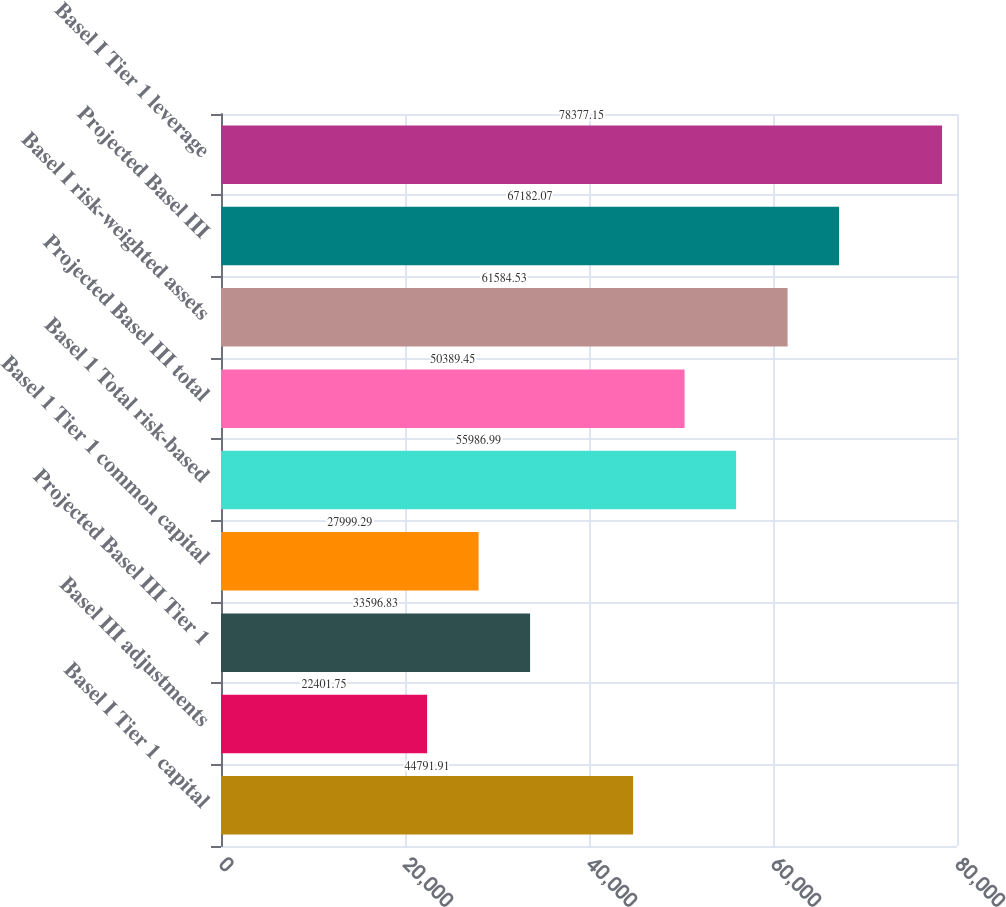<chart> <loc_0><loc_0><loc_500><loc_500><bar_chart><fcel>Basel I Tier 1 capital<fcel>Basel III adjustments<fcel>Projected Basel III Tier 1<fcel>Basel 1 Tier 1 common capital<fcel>Basel 1 Total risk-based<fcel>Projected Basel III total<fcel>Basel I risk-weighted assets<fcel>Projected Basel III<fcel>Basel I Tier 1 leverage<nl><fcel>44791.9<fcel>22401.8<fcel>33596.8<fcel>27999.3<fcel>55987<fcel>50389.4<fcel>61584.5<fcel>67182.1<fcel>78377.1<nl></chart> 